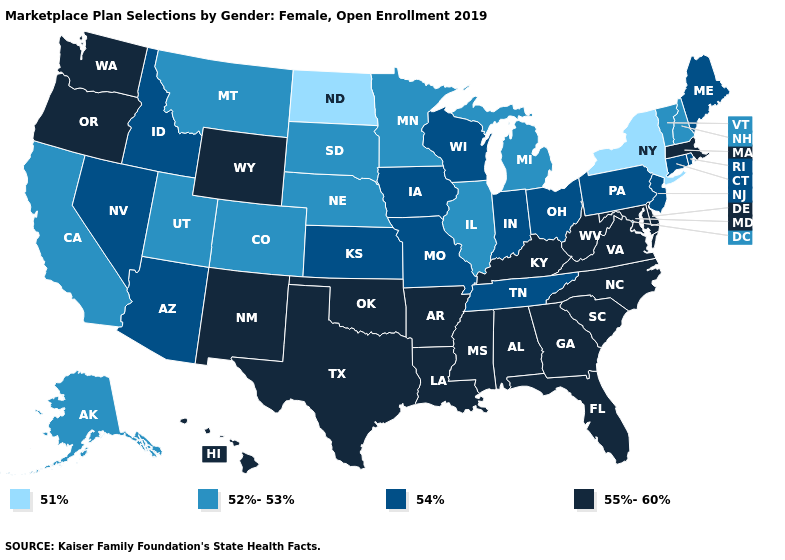What is the value of Hawaii?
Write a very short answer. 55%-60%. Does the map have missing data?
Give a very brief answer. No. Among the states that border Vermont , does New York have the lowest value?
Write a very short answer. Yes. How many symbols are there in the legend?
Answer briefly. 4. Does Nebraska have the same value as Vermont?
Be succinct. Yes. Which states hav the highest value in the West?
Be succinct. Hawaii, New Mexico, Oregon, Washington, Wyoming. Which states have the lowest value in the West?
Short answer required. Alaska, California, Colorado, Montana, Utah. Which states have the highest value in the USA?
Answer briefly. Alabama, Arkansas, Delaware, Florida, Georgia, Hawaii, Kentucky, Louisiana, Maryland, Massachusetts, Mississippi, New Mexico, North Carolina, Oklahoma, Oregon, South Carolina, Texas, Virginia, Washington, West Virginia, Wyoming. Name the states that have a value in the range 51%?
Concise answer only. New York, North Dakota. Name the states that have a value in the range 55%-60%?
Quick response, please. Alabama, Arkansas, Delaware, Florida, Georgia, Hawaii, Kentucky, Louisiana, Maryland, Massachusetts, Mississippi, New Mexico, North Carolina, Oklahoma, Oregon, South Carolina, Texas, Virginia, Washington, West Virginia, Wyoming. Among the states that border Georgia , does Tennessee have the lowest value?
Concise answer only. Yes. Which states have the lowest value in the USA?
Short answer required. New York, North Dakota. Among the states that border Georgia , which have the highest value?
Quick response, please. Alabama, Florida, North Carolina, South Carolina. 